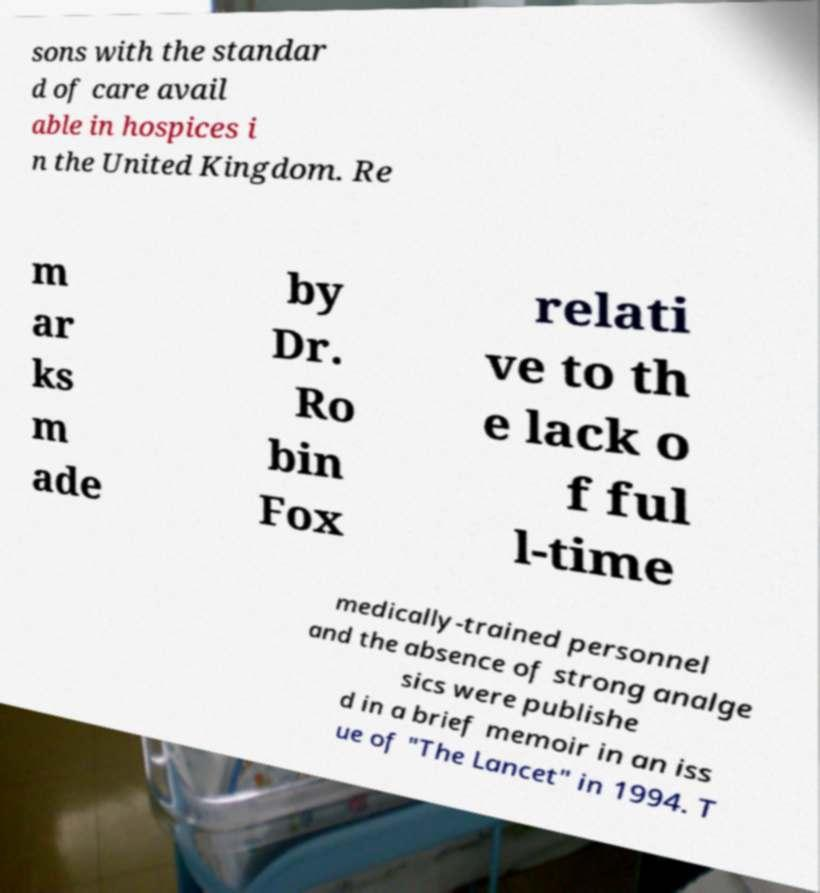Please read and relay the text visible in this image. What does it say? sons with the standar d of care avail able in hospices i n the United Kingdom. Re m ar ks m ade by Dr. Ro bin Fox relati ve to th e lack o f ful l-time medically-trained personnel and the absence of strong analge sics were publishe d in a brief memoir in an iss ue of "The Lancet" in 1994. T 